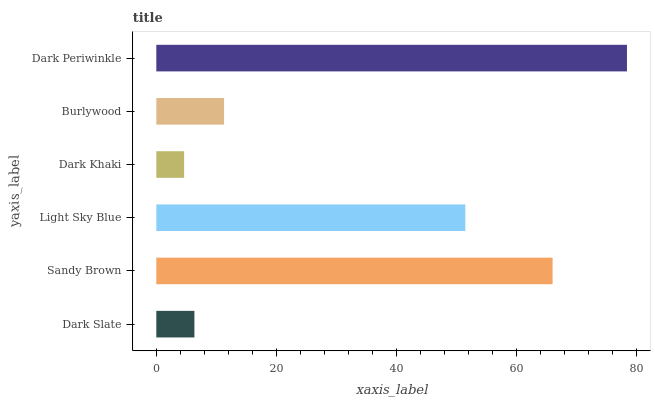Is Dark Khaki the minimum?
Answer yes or no. Yes. Is Dark Periwinkle the maximum?
Answer yes or no. Yes. Is Sandy Brown the minimum?
Answer yes or no. No. Is Sandy Brown the maximum?
Answer yes or no. No. Is Sandy Brown greater than Dark Slate?
Answer yes or no. Yes. Is Dark Slate less than Sandy Brown?
Answer yes or no. Yes. Is Dark Slate greater than Sandy Brown?
Answer yes or no. No. Is Sandy Brown less than Dark Slate?
Answer yes or no. No. Is Light Sky Blue the high median?
Answer yes or no. Yes. Is Burlywood the low median?
Answer yes or no. Yes. Is Dark Khaki the high median?
Answer yes or no. No. Is Dark Khaki the low median?
Answer yes or no. No. 